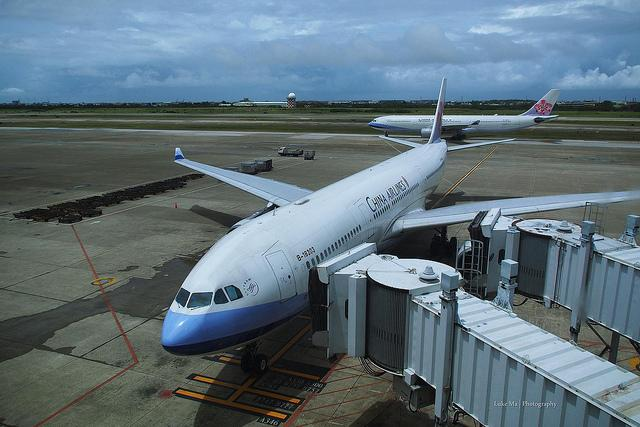What is the tunnel nearest the plane door called? Please explain your reasoning. jet bridge. The tunnel is a bridge. 